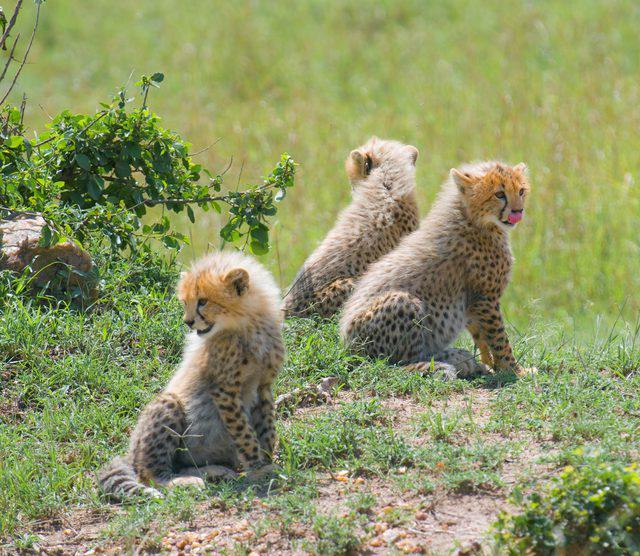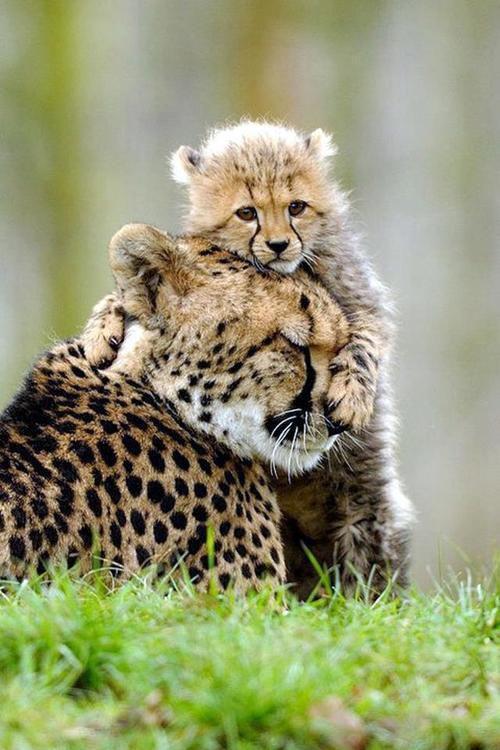The first image is the image on the left, the second image is the image on the right. Analyze the images presented: Is the assertion "A cheetah kitten is draping one front paw over part of another cheetah and has its head above the other cheetah." valid? Answer yes or no. Yes. The first image is the image on the left, the second image is the image on the right. Considering the images on both sides, is "A cub is shown hugging another leopard." valid? Answer yes or no. Yes. 